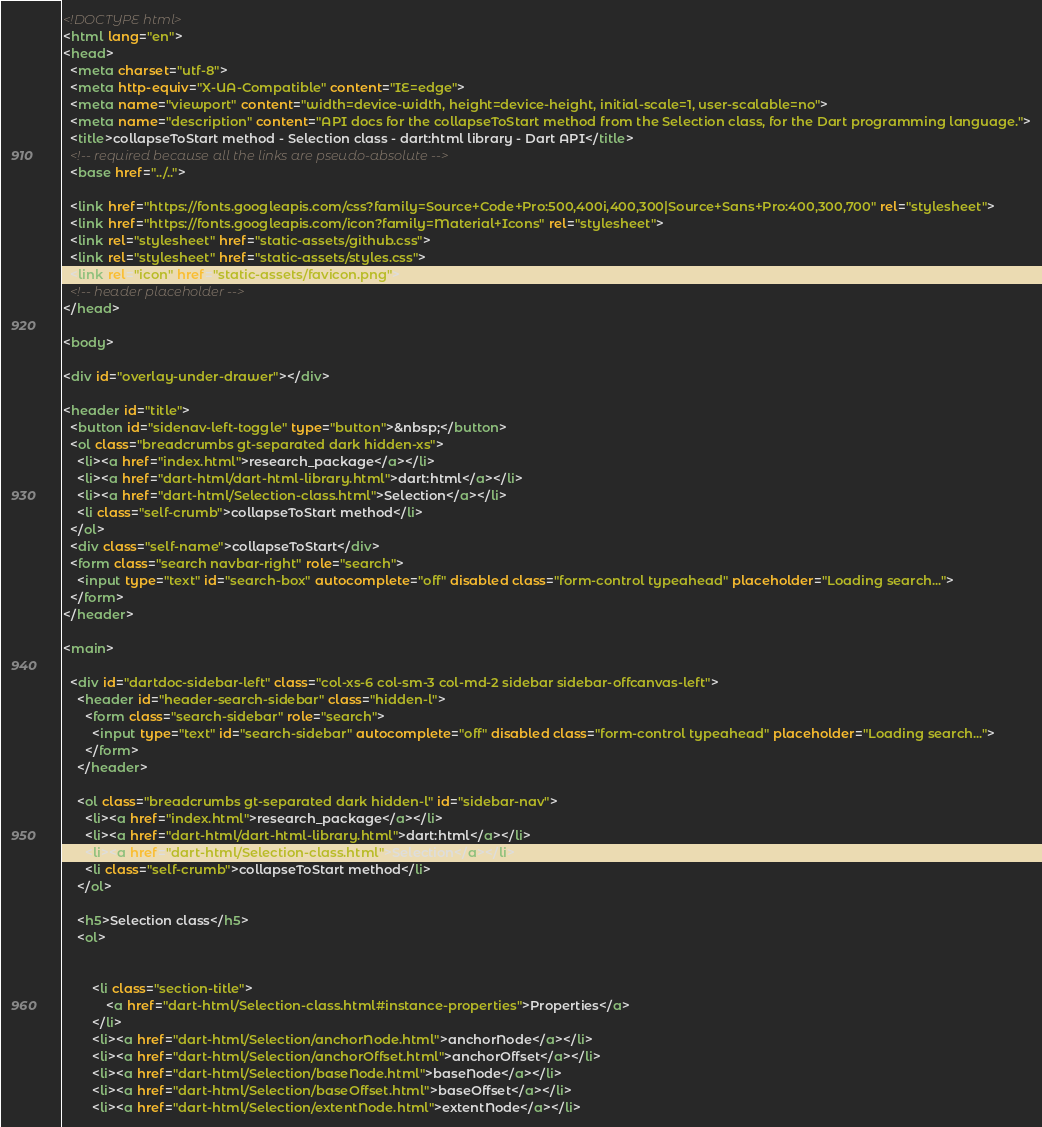<code> <loc_0><loc_0><loc_500><loc_500><_HTML_><!DOCTYPE html>
<html lang="en">
<head>
  <meta charset="utf-8">
  <meta http-equiv="X-UA-Compatible" content="IE=edge">
  <meta name="viewport" content="width=device-width, height=device-height, initial-scale=1, user-scalable=no">
  <meta name="description" content="API docs for the collapseToStart method from the Selection class, for the Dart programming language.">
  <title>collapseToStart method - Selection class - dart:html library - Dart API</title>
  <!-- required because all the links are pseudo-absolute -->
  <base href="../..">

  <link href="https://fonts.googleapis.com/css?family=Source+Code+Pro:500,400i,400,300|Source+Sans+Pro:400,300,700" rel="stylesheet">
  <link href="https://fonts.googleapis.com/icon?family=Material+Icons" rel="stylesheet">
  <link rel="stylesheet" href="static-assets/github.css">
  <link rel="stylesheet" href="static-assets/styles.css">
  <link rel="icon" href="static-assets/favicon.png">
  <!-- header placeholder -->
</head>

<body>

<div id="overlay-under-drawer"></div>

<header id="title">
  <button id="sidenav-left-toggle" type="button">&nbsp;</button>
  <ol class="breadcrumbs gt-separated dark hidden-xs">
    <li><a href="index.html">research_package</a></li>
    <li><a href="dart-html/dart-html-library.html">dart:html</a></li>
    <li><a href="dart-html/Selection-class.html">Selection</a></li>
    <li class="self-crumb">collapseToStart method</li>
  </ol>
  <div class="self-name">collapseToStart</div>
  <form class="search navbar-right" role="search">
    <input type="text" id="search-box" autocomplete="off" disabled class="form-control typeahead" placeholder="Loading search...">
  </form>
</header>

<main>

  <div id="dartdoc-sidebar-left" class="col-xs-6 col-sm-3 col-md-2 sidebar sidebar-offcanvas-left">
    <header id="header-search-sidebar" class="hidden-l">
      <form class="search-sidebar" role="search">
        <input type="text" id="search-sidebar" autocomplete="off" disabled class="form-control typeahead" placeholder="Loading search...">
      </form>
    </header>
    
    <ol class="breadcrumbs gt-separated dark hidden-l" id="sidebar-nav">
      <li><a href="index.html">research_package</a></li>
      <li><a href="dart-html/dart-html-library.html">dart:html</a></li>
      <li><a href="dart-html/Selection-class.html">Selection</a></li>
      <li class="self-crumb">collapseToStart method</li>
    </ol>
    
    <h5>Selection class</h5>
    <ol>
    
    
        <li class="section-title">
            <a href="dart-html/Selection-class.html#instance-properties">Properties</a>
        </li>
        <li><a href="dart-html/Selection/anchorNode.html">anchorNode</a></li>
        <li><a href="dart-html/Selection/anchorOffset.html">anchorOffset</a></li>
        <li><a href="dart-html/Selection/baseNode.html">baseNode</a></li>
        <li><a href="dart-html/Selection/baseOffset.html">baseOffset</a></li>
        <li><a href="dart-html/Selection/extentNode.html">extentNode</a></li></code> 